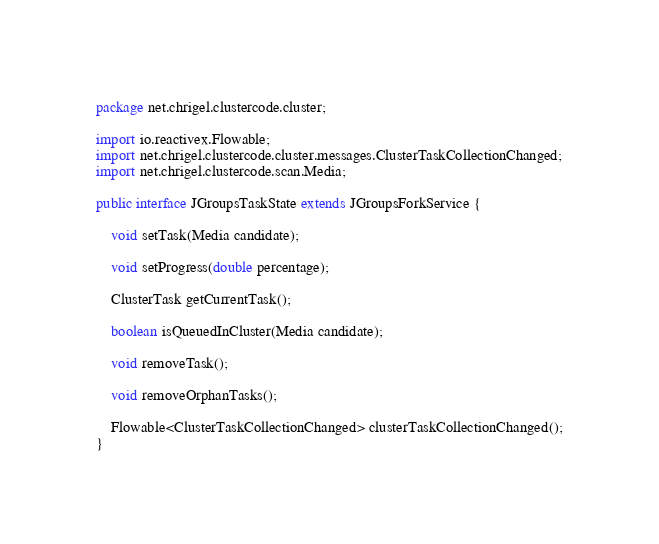<code> <loc_0><loc_0><loc_500><loc_500><_Java_>package net.chrigel.clustercode.cluster;

import io.reactivex.Flowable;
import net.chrigel.clustercode.cluster.messages.ClusterTaskCollectionChanged;
import net.chrigel.clustercode.scan.Media;

public interface JGroupsTaskState extends JGroupsForkService {

    void setTask(Media candidate);

    void setProgress(double percentage);

    ClusterTask getCurrentTask();

    boolean isQueuedInCluster(Media candidate);

    void removeTask();

    void removeOrphanTasks();

    Flowable<ClusterTaskCollectionChanged> clusterTaskCollectionChanged();
}
</code> 